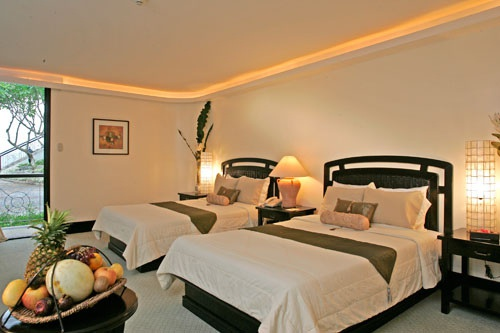Describe the objects in this image and their specific colors. I can see bed in gray, darkgray, tan, and black tones, bed in gray, tan, and black tones, apple in gray, orange, brown, red, and maroon tones, apple in gray, black, maroon, and brown tones, and apple in gray, orange, brown, red, and salmon tones in this image. 